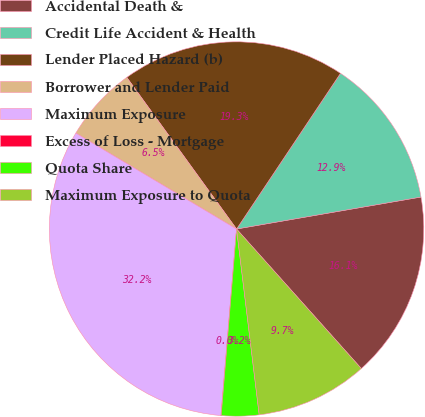Convert chart to OTSL. <chart><loc_0><loc_0><loc_500><loc_500><pie_chart><fcel>Accidental Death &<fcel>Credit Life Accident & Health<fcel>Lender Placed Hazard (b)<fcel>Borrower and Lender Paid<fcel>Maximum Exposure<fcel>Excess of Loss - Mortgage<fcel>Quota Share<fcel>Maximum Exposure to Quota<nl><fcel>16.12%<fcel>12.9%<fcel>19.34%<fcel>6.46%<fcel>32.23%<fcel>0.02%<fcel>3.24%<fcel>9.68%<nl></chart> 